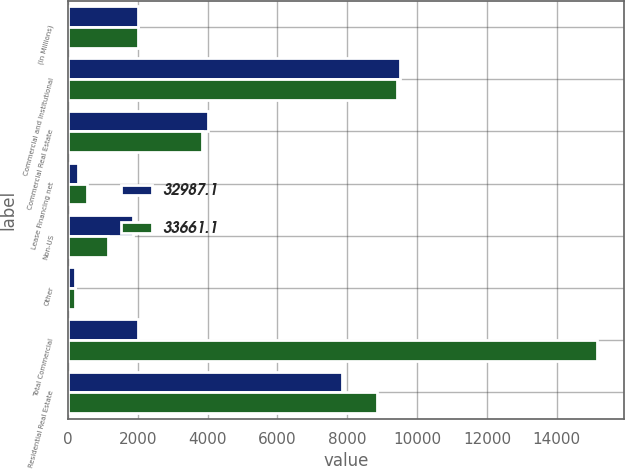Convert chart. <chart><loc_0><loc_0><loc_500><loc_500><stacked_bar_chart><ecel><fcel>(In Millions)<fcel>Commercial and Institutional<fcel>Commercial Real Estate<fcel>Lease Financing net<fcel>Non-US<fcel>Other<fcel>Total Commercial<fcel>Residential Real Estate<nl><fcel>32987.1<fcel>2016<fcel>9523<fcel>4002.5<fcel>293.9<fcel>1877.8<fcel>205.1<fcel>2016<fcel>7841.9<nl><fcel>33661.1<fcel>2015<fcel>9431.5<fcel>3848.8<fcel>544.4<fcel>1137.7<fcel>194.1<fcel>15156.5<fcel>8850.7<nl></chart> 